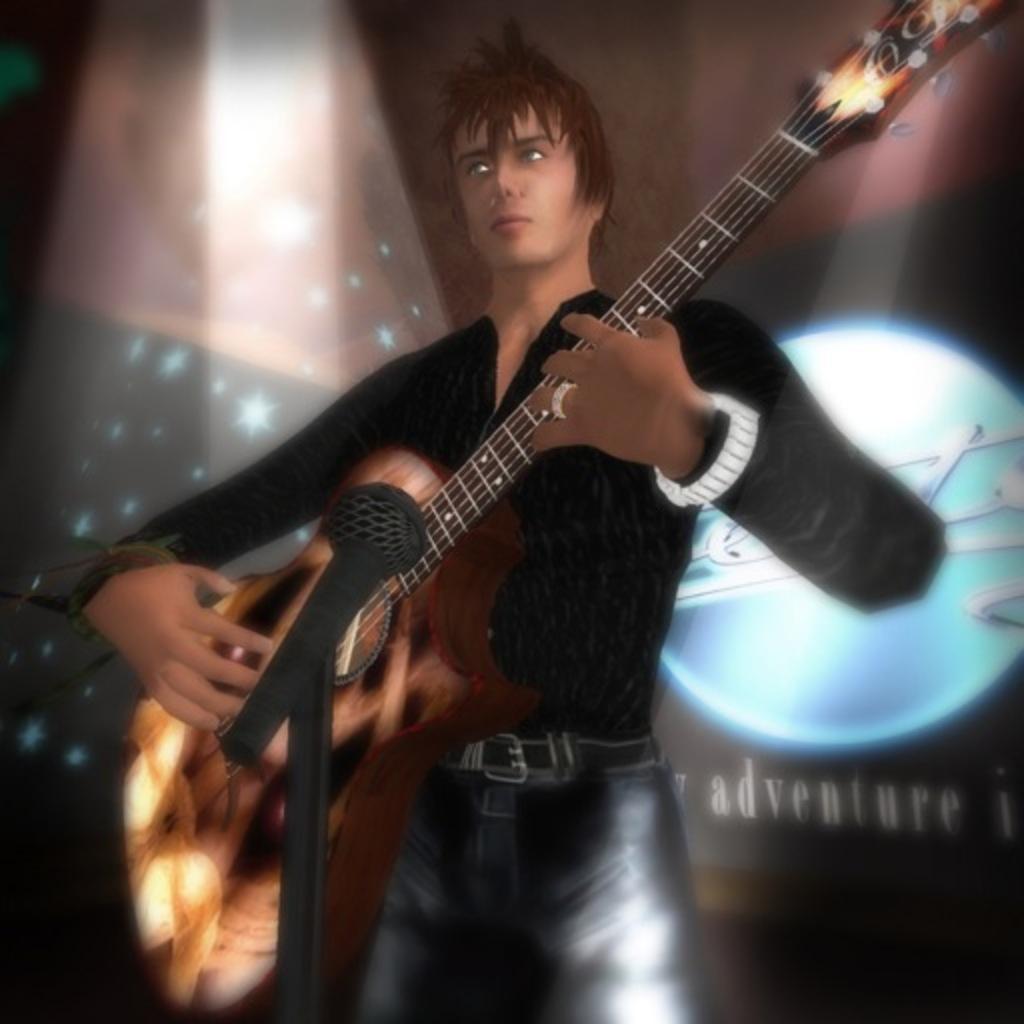Describe this image in one or two sentences. In this image I can see the animated picture and I can also see the person standing and holding the musical instrument. In the background I can see few lights. 